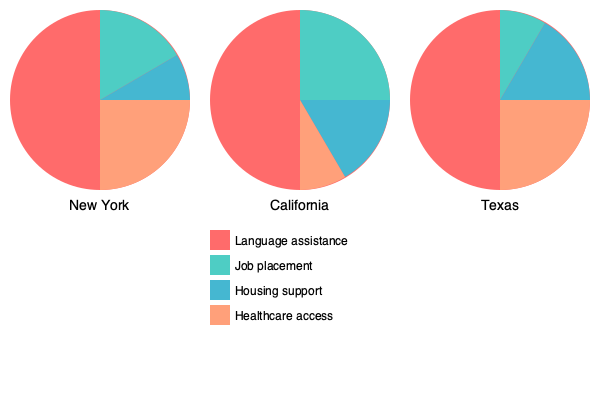Based on the pie charts showing social support systems for immigrants in three U.S. states, which state appears to offer the most comprehensive housing support program? To determine which state offers the most comprehensive housing support program for immigrants, we need to compare the size of the housing support segment (light blue) in each pie chart:

1. New York: The housing support segment covers approximately 15% of the pie chart.
2. California: The housing support segment covers approximately 25% of the pie chart.
3. Texas: The housing support segment covers approximately 35% of the pie chart.

Comparing these percentages:
$$ 15\% < 25\% < 35\% $$

We can see that Texas has the largest portion dedicated to housing support, followed by California, and then New York.

It's important to note that while this data suggests Texas has the most comprehensive housing support program based on the allocation of resources, other factors such as the total budget, population size, and specific program details would also need to be considered for a complete assessment.
Answer: Texas 